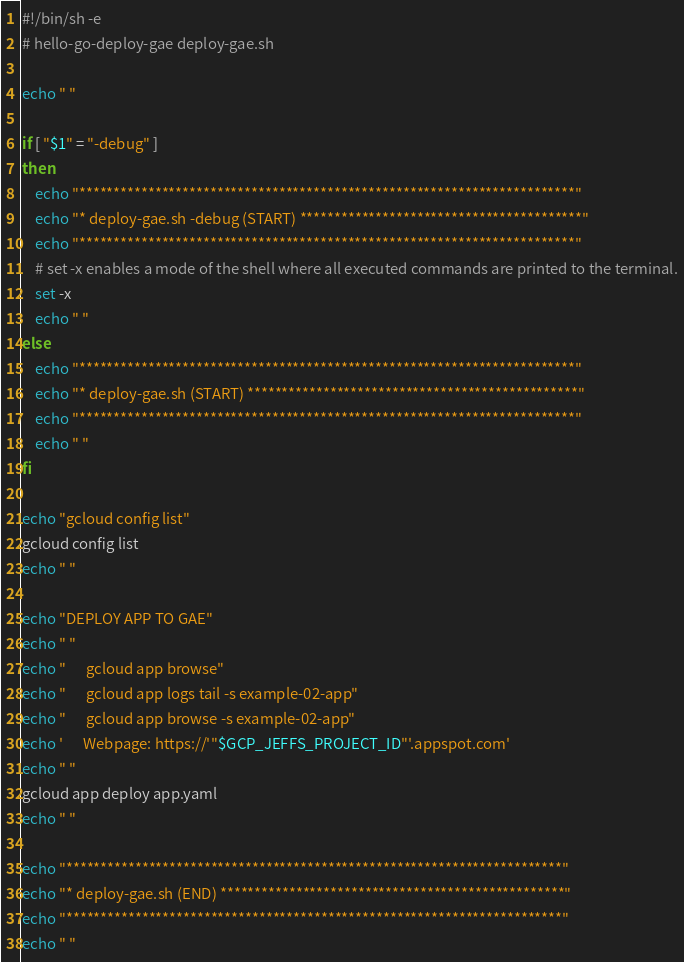Convert code to text. <code><loc_0><loc_0><loc_500><loc_500><_Bash_>#!/bin/sh -e 
# hello-go-deploy-gae deploy-gae.sh

echo " "

if [ "$1" = "-debug" ]
then
    echo "************************************************************************"
    echo "* deploy-gae.sh -debug (START) *****************************************"
    echo "************************************************************************"
    # set -x enables a mode of the shell where all executed commands are printed to the terminal.
    set -x
    echo " "
else
    echo "************************************************************************"
    echo "* deploy-gae.sh (START) ************************************************"
    echo "************************************************************************"
    echo " "
fi

echo "gcloud config list"
gcloud config list
echo " "

echo "DEPLOY APP TO GAE"
echo " "
echo "      gcloud app browse"
echo "      gcloud app logs tail -s example-02-app"
echo "      gcloud app browse -s example-02-app"
echo '      Webpage: https://'"$GCP_JEFFS_PROJECT_ID"'.appspot.com'
echo " "
gcloud app deploy app.yaml
echo " "

echo "************************************************************************"
echo "* deploy-gae.sh (END) **************************************************"
echo "************************************************************************"
echo " "
</code> 